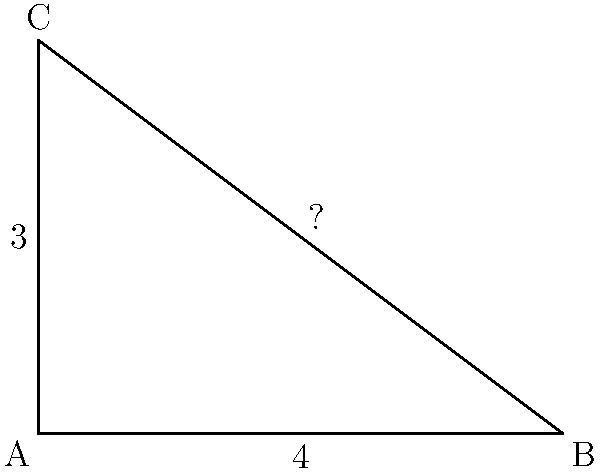In your latest historical novel set in ancient Greece, you're describing a scene where Pythagoras is teaching his theorem to his students. To illustrate this concept, you decide to include a practical example. Given a right triangle ABC with the length of the base (AB) being 4 units and the height (AC) being 3 units, what would be the length of the hypotenuse (BC)? To find the length of the hypotenuse, we'll use the Pythagorean theorem, which states that in a right triangle, the square of the length of the hypotenuse is equal to the sum of squares of the other two sides.

Let's follow these steps:

1. Identify the known sides:
   Base (AB) = 4 units
   Height (AC) = 3 units

2. Apply the Pythagorean theorem:
   $a^2 + b^2 = c^2$, where c is the hypotenuse

3. Substitute the known values:
   $4^2 + 3^2 = c^2$

4. Calculate the squares:
   $16 + 9 = c^2$

5. Add the left side:
   $25 = c^2$

6. Take the square root of both sides:
   $\sqrt{25} = c$

7. Simplify:
   $5 = c$

Therefore, the length of the hypotenuse (BC) is 5 units.
Answer: 5 units 